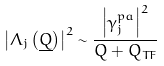Convert formula to latex. <formula><loc_0><loc_0><loc_500><loc_500>\left | \Lambda _ { j } \left ( \underline { Q } \right ) \right | ^ { 2 } \sim \frac { \left | \gamma _ { j } ^ { p a } \right | ^ { 2 } } { Q + Q _ { T F } }</formula> 